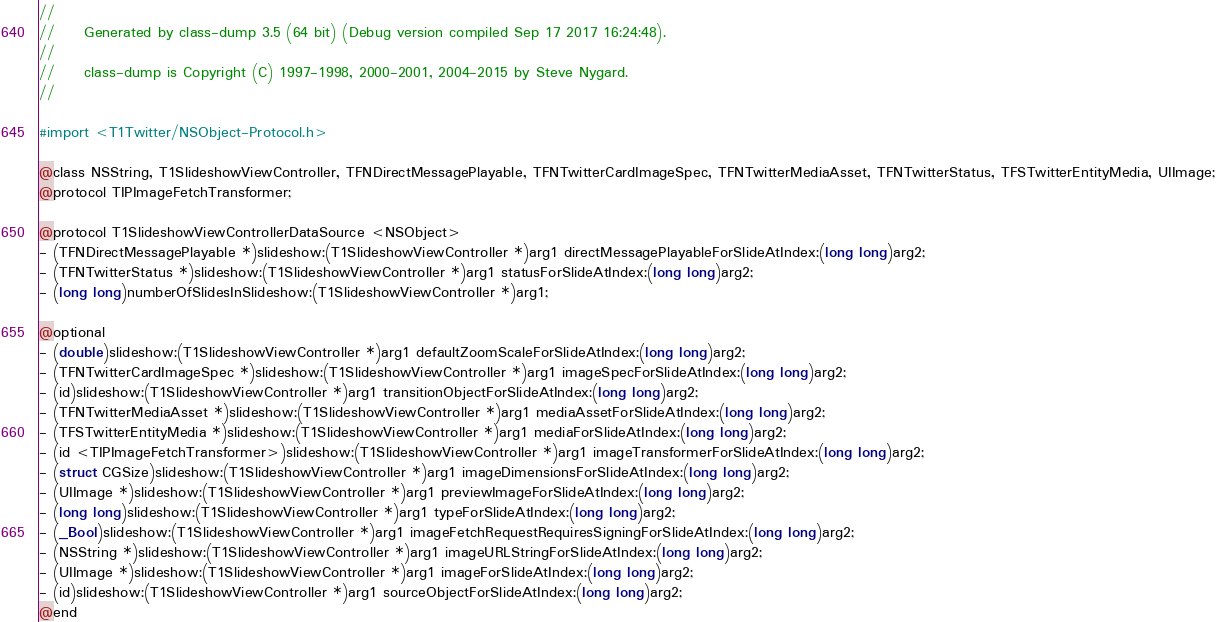Convert code to text. <code><loc_0><loc_0><loc_500><loc_500><_C_>//
//     Generated by class-dump 3.5 (64 bit) (Debug version compiled Sep 17 2017 16:24:48).
//
//     class-dump is Copyright (C) 1997-1998, 2000-2001, 2004-2015 by Steve Nygard.
//

#import <T1Twitter/NSObject-Protocol.h>

@class NSString, T1SlideshowViewController, TFNDirectMessagePlayable, TFNTwitterCardImageSpec, TFNTwitterMediaAsset, TFNTwitterStatus, TFSTwitterEntityMedia, UIImage;
@protocol TIPImageFetchTransformer;

@protocol T1SlideshowViewControllerDataSource <NSObject>
- (TFNDirectMessagePlayable *)slideshow:(T1SlideshowViewController *)arg1 directMessagePlayableForSlideAtIndex:(long long)arg2;
- (TFNTwitterStatus *)slideshow:(T1SlideshowViewController *)arg1 statusForSlideAtIndex:(long long)arg2;
- (long long)numberOfSlidesInSlideshow:(T1SlideshowViewController *)arg1;

@optional
- (double)slideshow:(T1SlideshowViewController *)arg1 defaultZoomScaleForSlideAtIndex:(long long)arg2;
- (TFNTwitterCardImageSpec *)slideshow:(T1SlideshowViewController *)arg1 imageSpecForSlideAtIndex:(long long)arg2;
- (id)slideshow:(T1SlideshowViewController *)arg1 transitionObjectForSlideAtIndex:(long long)arg2;
- (TFNTwitterMediaAsset *)slideshow:(T1SlideshowViewController *)arg1 mediaAssetForSlideAtIndex:(long long)arg2;
- (TFSTwitterEntityMedia *)slideshow:(T1SlideshowViewController *)arg1 mediaForSlideAtIndex:(long long)arg2;
- (id <TIPImageFetchTransformer>)slideshow:(T1SlideshowViewController *)arg1 imageTransformerForSlideAtIndex:(long long)arg2;
- (struct CGSize)slideshow:(T1SlideshowViewController *)arg1 imageDimensionsForSlideAtIndex:(long long)arg2;
- (UIImage *)slideshow:(T1SlideshowViewController *)arg1 previewImageForSlideAtIndex:(long long)arg2;
- (long long)slideshow:(T1SlideshowViewController *)arg1 typeForSlideAtIndex:(long long)arg2;
- (_Bool)slideshow:(T1SlideshowViewController *)arg1 imageFetchRequestRequiresSigningForSlideAtIndex:(long long)arg2;
- (NSString *)slideshow:(T1SlideshowViewController *)arg1 imageURLStringForSlideAtIndex:(long long)arg2;
- (UIImage *)slideshow:(T1SlideshowViewController *)arg1 imageForSlideAtIndex:(long long)arg2;
- (id)slideshow:(T1SlideshowViewController *)arg1 sourceObjectForSlideAtIndex:(long long)arg2;
@end

</code> 